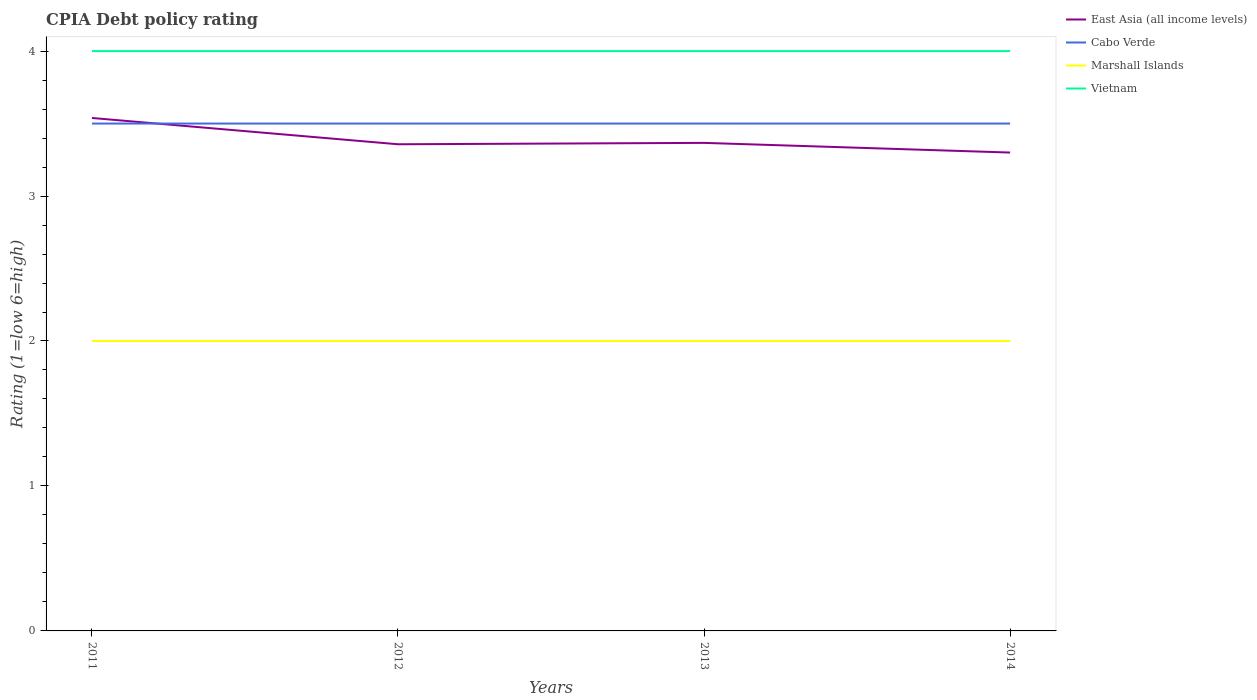Does the line corresponding to Marshall Islands intersect with the line corresponding to Cabo Verde?
Offer a terse response. No. Is the number of lines equal to the number of legend labels?
Your response must be concise. Yes. Across all years, what is the maximum CPIA rating in Cabo Verde?
Provide a short and direct response. 3.5. What is the total CPIA rating in Vietnam in the graph?
Provide a short and direct response. 0. What is the difference between the highest and the lowest CPIA rating in East Asia (all income levels)?
Make the answer very short. 1. Is the CPIA rating in Vietnam strictly greater than the CPIA rating in Marshall Islands over the years?
Your response must be concise. No. How many lines are there?
Offer a terse response. 4. What is the difference between two consecutive major ticks on the Y-axis?
Your response must be concise. 1. Are the values on the major ticks of Y-axis written in scientific E-notation?
Provide a succinct answer. No. Does the graph contain any zero values?
Keep it short and to the point. No. Does the graph contain grids?
Make the answer very short. No. How many legend labels are there?
Offer a terse response. 4. What is the title of the graph?
Your answer should be compact. CPIA Debt policy rating. Does "South Sudan" appear as one of the legend labels in the graph?
Make the answer very short. No. What is the label or title of the X-axis?
Offer a terse response. Years. What is the label or title of the Y-axis?
Ensure brevity in your answer.  Rating (1=low 6=high). What is the Rating (1=low 6=high) of East Asia (all income levels) in 2011?
Your response must be concise. 3.54. What is the Rating (1=low 6=high) of Vietnam in 2011?
Your response must be concise. 4. What is the Rating (1=low 6=high) of East Asia (all income levels) in 2012?
Keep it short and to the point. 3.36. What is the Rating (1=low 6=high) of Vietnam in 2012?
Make the answer very short. 4. What is the Rating (1=low 6=high) of East Asia (all income levels) in 2013?
Ensure brevity in your answer.  3.37. What is the Rating (1=low 6=high) of Vietnam in 2013?
Provide a short and direct response. 4. What is the Rating (1=low 6=high) in East Asia (all income levels) in 2014?
Provide a succinct answer. 3.3. Across all years, what is the maximum Rating (1=low 6=high) in East Asia (all income levels)?
Ensure brevity in your answer.  3.54. Across all years, what is the maximum Rating (1=low 6=high) in Cabo Verde?
Give a very brief answer. 3.5. Across all years, what is the minimum Rating (1=low 6=high) of East Asia (all income levels)?
Make the answer very short. 3.3. Across all years, what is the minimum Rating (1=low 6=high) of Marshall Islands?
Offer a very short reply. 2. What is the total Rating (1=low 6=high) in East Asia (all income levels) in the graph?
Offer a very short reply. 13.56. What is the total Rating (1=low 6=high) in Cabo Verde in the graph?
Offer a very short reply. 14. What is the total Rating (1=low 6=high) of Marshall Islands in the graph?
Offer a very short reply. 8. What is the difference between the Rating (1=low 6=high) of East Asia (all income levels) in 2011 and that in 2012?
Keep it short and to the point. 0.18. What is the difference between the Rating (1=low 6=high) of Vietnam in 2011 and that in 2012?
Keep it short and to the point. 0. What is the difference between the Rating (1=low 6=high) in East Asia (all income levels) in 2011 and that in 2013?
Ensure brevity in your answer.  0.17. What is the difference between the Rating (1=low 6=high) of Cabo Verde in 2011 and that in 2013?
Your answer should be very brief. 0. What is the difference between the Rating (1=low 6=high) of Marshall Islands in 2011 and that in 2013?
Provide a short and direct response. 0. What is the difference between the Rating (1=low 6=high) in East Asia (all income levels) in 2011 and that in 2014?
Ensure brevity in your answer.  0.24. What is the difference between the Rating (1=low 6=high) of Marshall Islands in 2011 and that in 2014?
Give a very brief answer. 0. What is the difference between the Rating (1=low 6=high) of East Asia (all income levels) in 2012 and that in 2013?
Offer a very short reply. -0.01. What is the difference between the Rating (1=low 6=high) of Marshall Islands in 2012 and that in 2013?
Make the answer very short. 0. What is the difference between the Rating (1=low 6=high) in Vietnam in 2012 and that in 2013?
Provide a short and direct response. 0. What is the difference between the Rating (1=low 6=high) in East Asia (all income levels) in 2012 and that in 2014?
Give a very brief answer. 0.06. What is the difference between the Rating (1=low 6=high) in Cabo Verde in 2012 and that in 2014?
Offer a very short reply. 0. What is the difference between the Rating (1=low 6=high) in East Asia (all income levels) in 2013 and that in 2014?
Your answer should be very brief. 0.07. What is the difference between the Rating (1=low 6=high) in Cabo Verde in 2013 and that in 2014?
Make the answer very short. 0. What is the difference between the Rating (1=low 6=high) in East Asia (all income levels) in 2011 and the Rating (1=low 6=high) in Cabo Verde in 2012?
Your answer should be compact. 0.04. What is the difference between the Rating (1=low 6=high) in East Asia (all income levels) in 2011 and the Rating (1=low 6=high) in Marshall Islands in 2012?
Give a very brief answer. 1.54. What is the difference between the Rating (1=low 6=high) of East Asia (all income levels) in 2011 and the Rating (1=low 6=high) of Vietnam in 2012?
Your response must be concise. -0.46. What is the difference between the Rating (1=low 6=high) of Cabo Verde in 2011 and the Rating (1=low 6=high) of Marshall Islands in 2012?
Offer a terse response. 1.5. What is the difference between the Rating (1=low 6=high) of Cabo Verde in 2011 and the Rating (1=low 6=high) of Vietnam in 2012?
Offer a terse response. -0.5. What is the difference between the Rating (1=low 6=high) in East Asia (all income levels) in 2011 and the Rating (1=low 6=high) in Cabo Verde in 2013?
Your response must be concise. 0.04. What is the difference between the Rating (1=low 6=high) of East Asia (all income levels) in 2011 and the Rating (1=low 6=high) of Marshall Islands in 2013?
Your answer should be very brief. 1.54. What is the difference between the Rating (1=low 6=high) in East Asia (all income levels) in 2011 and the Rating (1=low 6=high) in Vietnam in 2013?
Ensure brevity in your answer.  -0.46. What is the difference between the Rating (1=low 6=high) of Cabo Verde in 2011 and the Rating (1=low 6=high) of Marshall Islands in 2013?
Your response must be concise. 1.5. What is the difference between the Rating (1=low 6=high) of Cabo Verde in 2011 and the Rating (1=low 6=high) of Vietnam in 2013?
Your response must be concise. -0.5. What is the difference between the Rating (1=low 6=high) of Marshall Islands in 2011 and the Rating (1=low 6=high) of Vietnam in 2013?
Your response must be concise. -2. What is the difference between the Rating (1=low 6=high) in East Asia (all income levels) in 2011 and the Rating (1=low 6=high) in Cabo Verde in 2014?
Offer a very short reply. 0.04. What is the difference between the Rating (1=low 6=high) of East Asia (all income levels) in 2011 and the Rating (1=low 6=high) of Marshall Islands in 2014?
Offer a very short reply. 1.54. What is the difference between the Rating (1=low 6=high) of East Asia (all income levels) in 2011 and the Rating (1=low 6=high) of Vietnam in 2014?
Offer a terse response. -0.46. What is the difference between the Rating (1=low 6=high) in Cabo Verde in 2011 and the Rating (1=low 6=high) in Marshall Islands in 2014?
Your answer should be compact. 1.5. What is the difference between the Rating (1=low 6=high) in Cabo Verde in 2011 and the Rating (1=low 6=high) in Vietnam in 2014?
Provide a short and direct response. -0.5. What is the difference between the Rating (1=low 6=high) of Marshall Islands in 2011 and the Rating (1=low 6=high) of Vietnam in 2014?
Give a very brief answer. -2. What is the difference between the Rating (1=low 6=high) of East Asia (all income levels) in 2012 and the Rating (1=low 6=high) of Cabo Verde in 2013?
Offer a very short reply. -0.14. What is the difference between the Rating (1=low 6=high) of East Asia (all income levels) in 2012 and the Rating (1=low 6=high) of Marshall Islands in 2013?
Offer a terse response. 1.36. What is the difference between the Rating (1=low 6=high) of East Asia (all income levels) in 2012 and the Rating (1=low 6=high) of Vietnam in 2013?
Provide a short and direct response. -0.64. What is the difference between the Rating (1=low 6=high) in Cabo Verde in 2012 and the Rating (1=low 6=high) in Marshall Islands in 2013?
Provide a short and direct response. 1.5. What is the difference between the Rating (1=low 6=high) of East Asia (all income levels) in 2012 and the Rating (1=low 6=high) of Cabo Verde in 2014?
Your answer should be compact. -0.14. What is the difference between the Rating (1=low 6=high) in East Asia (all income levels) in 2012 and the Rating (1=low 6=high) in Marshall Islands in 2014?
Give a very brief answer. 1.36. What is the difference between the Rating (1=low 6=high) of East Asia (all income levels) in 2012 and the Rating (1=low 6=high) of Vietnam in 2014?
Provide a succinct answer. -0.64. What is the difference between the Rating (1=low 6=high) in Cabo Verde in 2012 and the Rating (1=low 6=high) in Marshall Islands in 2014?
Provide a short and direct response. 1.5. What is the difference between the Rating (1=low 6=high) of East Asia (all income levels) in 2013 and the Rating (1=low 6=high) of Cabo Verde in 2014?
Provide a short and direct response. -0.13. What is the difference between the Rating (1=low 6=high) in East Asia (all income levels) in 2013 and the Rating (1=low 6=high) in Marshall Islands in 2014?
Your answer should be compact. 1.37. What is the difference between the Rating (1=low 6=high) of East Asia (all income levels) in 2013 and the Rating (1=low 6=high) of Vietnam in 2014?
Keep it short and to the point. -0.63. What is the difference between the Rating (1=low 6=high) of Cabo Verde in 2013 and the Rating (1=low 6=high) of Marshall Islands in 2014?
Ensure brevity in your answer.  1.5. What is the difference between the Rating (1=low 6=high) in Cabo Verde in 2013 and the Rating (1=low 6=high) in Vietnam in 2014?
Your answer should be very brief. -0.5. What is the average Rating (1=low 6=high) of East Asia (all income levels) per year?
Your answer should be compact. 3.39. What is the average Rating (1=low 6=high) of Cabo Verde per year?
Your answer should be compact. 3.5. What is the average Rating (1=low 6=high) in Marshall Islands per year?
Keep it short and to the point. 2. What is the average Rating (1=low 6=high) of Vietnam per year?
Your response must be concise. 4. In the year 2011, what is the difference between the Rating (1=low 6=high) in East Asia (all income levels) and Rating (1=low 6=high) in Cabo Verde?
Your answer should be compact. 0.04. In the year 2011, what is the difference between the Rating (1=low 6=high) in East Asia (all income levels) and Rating (1=low 6=high) in Marshall Islands?
Ensure brevity in your answer.  1.54. In the year 2011, what is the difference between the Rating (1=low 6=high) in East Asia (all income levels) and Rating (1=low 6=high) in Vietnam?
Your response must be concise. -0.46. In the year 2011, what is the difference between the Rating (1=low 6=high) in Cabo Verde and Rating (1=low 6=high) in Vietnam?
Provide a short and direct response. -0.5. In the year 2012, what is the difference between the Rating (1=low 6=high) in East Asia (all income levels) and Rating (1=low 6=high) in Cabo Verde?
Ensure brevity in your answer.  -0.14. In the year 2012, what is the difference between the Rating (1=low 6=high) in East Asia (all income levels) and Rating (1=low 6=high) in Marshall Islands?
Offer a terse response. 1.36. In the year 2012, what is the difference between the Rating (1=low 6=high) of East Asia (all income levels) and Rating (1=low 6=high) of Vietnam?
Provide a succinct answer. -0.64. In the year 2012, what is the difference between the Rating (1=low 6=high) in Cabo Verde and Rating (1=low 6=high) in Vietnam?
Ensure brevity in your answer.  -0.5. In the year 2013, what is the difference between the Rating (1=low 6=high) of East Asia (all income levels) and Rating (1=low 6=high) of Cabo Verde?
Your response must be concise. -0.13. In the year 2013, what is the difference between the Rating (1=low 6=high) in East Asia (all income levels) and Rating (1=low 6=high) in Marshall Islands?
Keep it short and to the point. 1.37. In the year 2013, what is the difference between the Rating (1=low 6=high) in East Asia (all income levels) and Rating (1=low 6=high) in Vietnam?
Provide a short and direct response. -0.63. In the year 2013, what is the difference between the Rating (1=low 6=high) of Cabo Verde and Rating (1=low 6=high) of Vietnam?
Offer a terse response. -0.5. In the year 2014, what is the difference between the Rating (1=low 6=high) of East Asia (all income levels) and Rating (1=low 6=high) of Cabo Verde?
Keep it short and to the point. -0.2. In the year 2014, what is the difference between the Rating (1=low 6=high) of East Asia (all income levels) and Rating (1=low 6=high) of Marshall Islands?
Offer a terse response. 1.3. In the year 2014, what is the difference between the Rating (1=low 6=high) in Cabo Verde and Rating (1=low 6=high) in Marshall Islands?
Provide a short and direct response. 1.5. In the year 2014, what is the difference between the Rating (1=low 6=high) of Cabo Verde and Rating (1=low 6=high) of Vietnam?
Provide a short and direct response. -0.5. What is the ratio of the Rating (1=low 6=high) in East Asia (all income levels) in 2011 to that in 2012?
Provide a short and direct response. 1.05. What is the ratio of the Rating (1=low 6=high) of Cabo Verde in 2011 to that in 2012?
Offer a terse response. 1. What is the ratio of the Rating (1=low 6=high) of Marshall Islands in 2011 to that in 2012?
Give a very brief answer. 1. What is the ratio of the Rating (1=low 6=high) in East Asia (all income levels) in 2011 to that in 2013?
Make the answer very short. 1.05. What is the ratio of the Rating (1=low 6=high) in East Asia (all income levels) in 2011 to that in 2014?
Provide a short and direct response. 1.07. What is the ratio of the Rating (1=low 6=high) in Cabo Verde in 2011 to that in 2014?
Your answer should be very brief. 1. What is the ratio of the Rating (1=low 6=high) of East Asia (all income levels) in 2012 to that in 2013?
Your answer should be very brief. 1. What is the ratio of the Rating (1=low 6=high) in Cabo Verde in 2012 to that in 2013?
Make the answer very short. 1. What is the ratio of the Rating (1=low 6=high) of East Asia (all income levels) in 2012 to that in 2014?
Keep it short and to the point. 1.02. What is the ratio of the Rating (1=low 6=high) in East Asia (all income levels) in 2013 to that in 2014?
Make the answer very short. 1.02. What is the ratio of the Rating (1=low 6=high) of Cabo Verde in 2013 to that in 2014?
Offer a terse response. 1. What is the ratio of the Rating (1=low 6=high) in Vietnam in 2013 to that in 2014?
Your response must be concise. 1. What is the difference between the highest and the second highest Rating (1=low 6=high) in East Asia (all income levels)?
Keep it short and to the point. 0.17. What is the difference between the highest and the second highest Rating (1=low 6=high) in Cabo Verde?
Provide a succinct answer. 0. What is the difference between the highest and the second highest Rating (1=low 6=high) of Vietnam?
Give a very brief answer. 0. What is the difference between the highest and the lowest Rating (1=low 6=high) in East Asia (all income levels)?
Provide a short and direct response. 0.24. What is the difference between the highest and the lowest Rating (1=low 6=high) of Marshall Islands?
Provide a short and direct response. 0. 